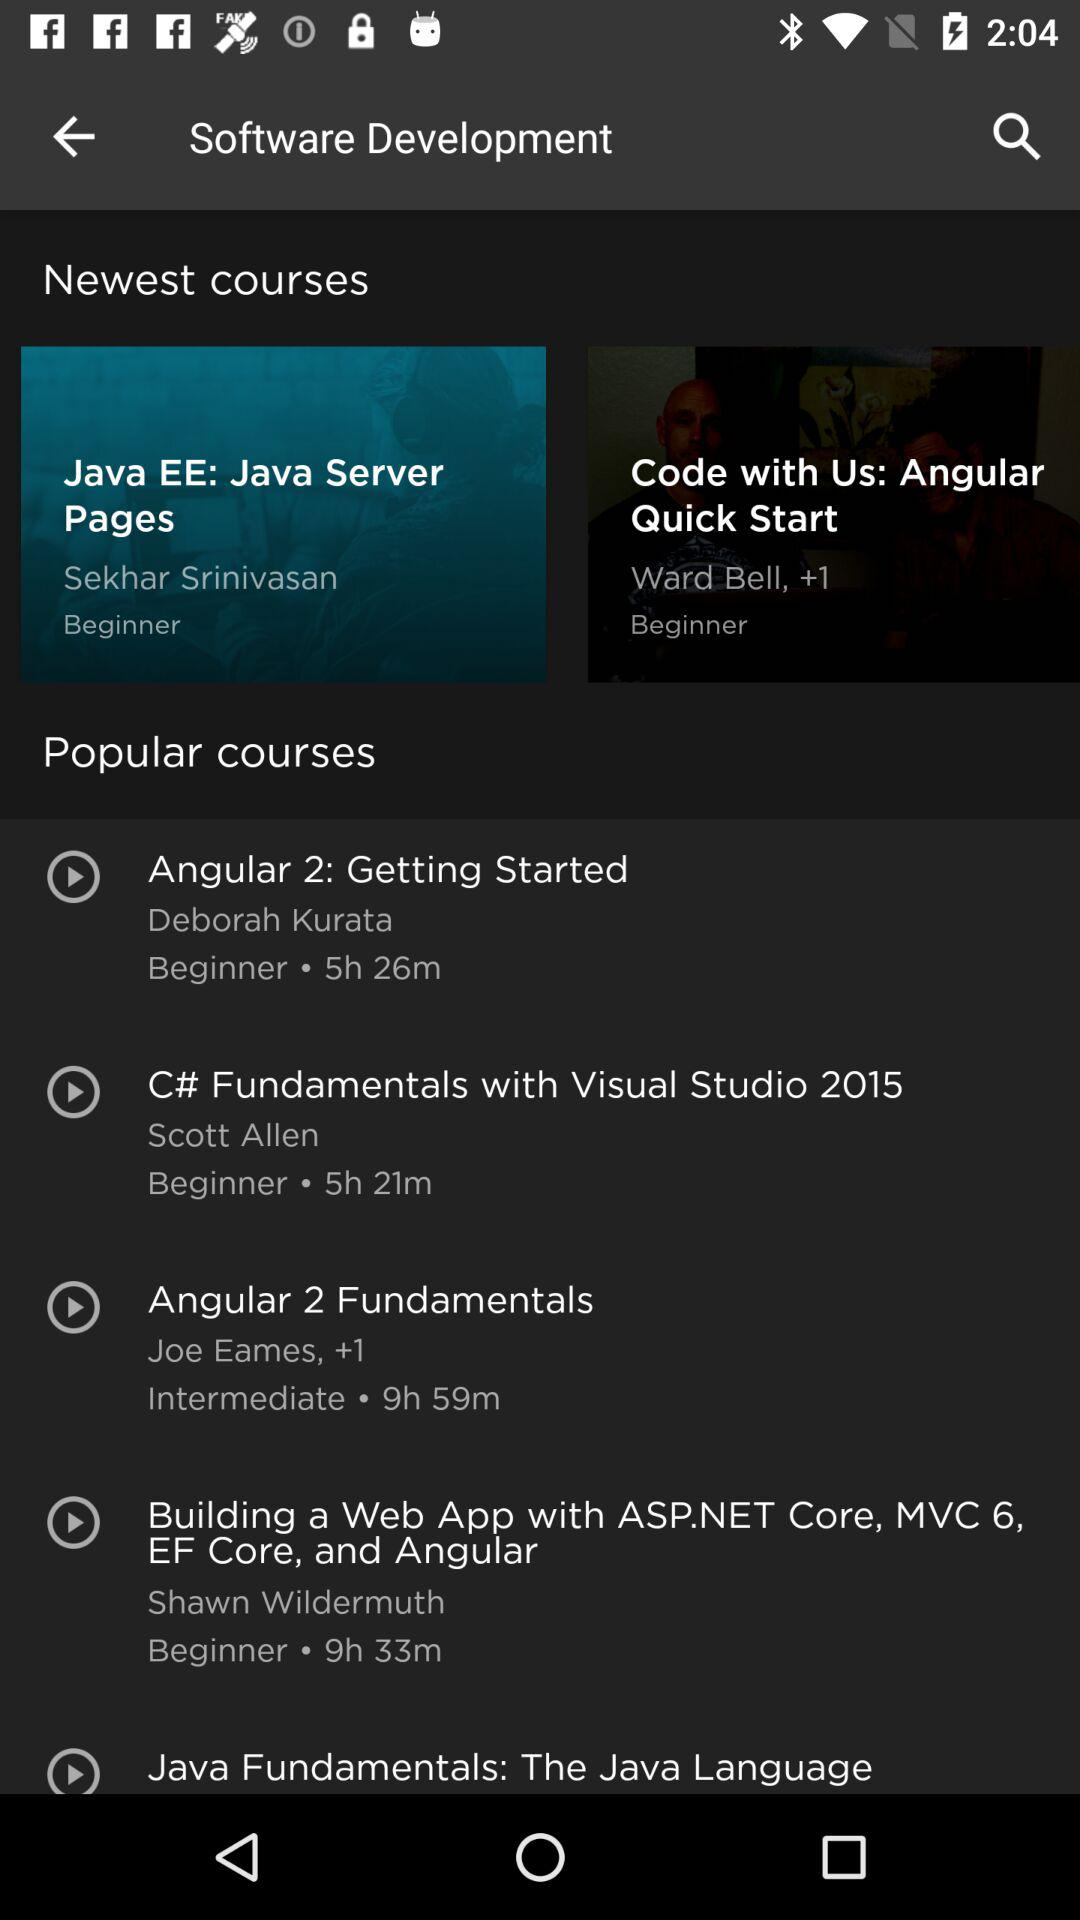What is the duration of the "C# Fundamentals with Visual Studio 2015" course? The duration of the "C# Fundamentals with Visual Studio 2015" is 5 hours and 21 minutes. 